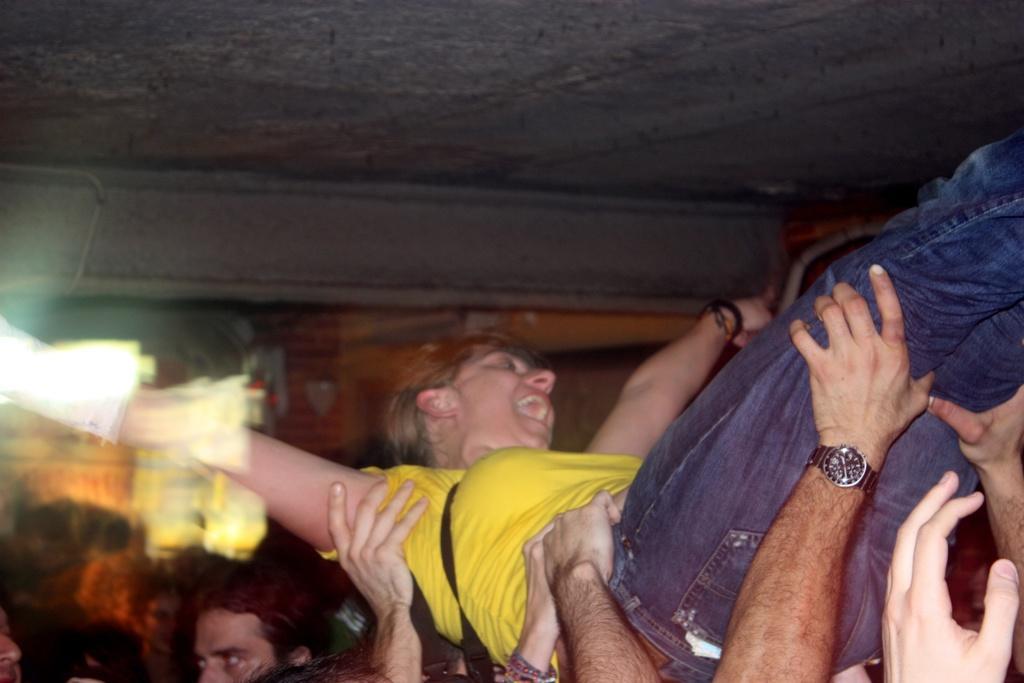Could you give a brief overview of what you see in this image? Many people are holding a lady wearing a yellow top and a jeans. She is wearing a wristband. A persons hand is visible and a watch is in his hand. 